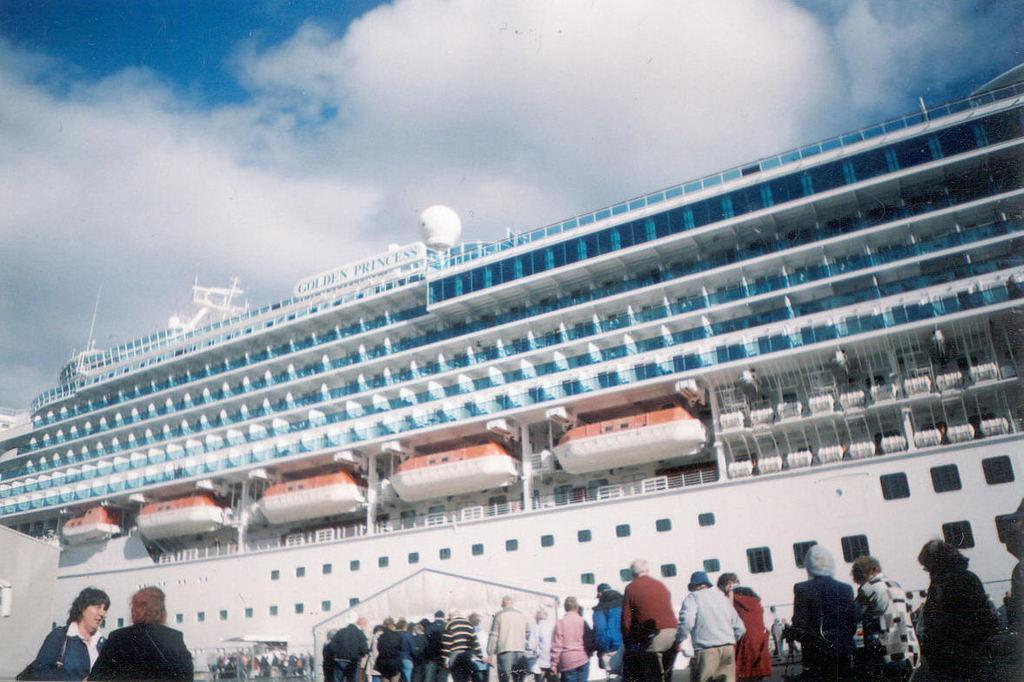What is the main subject of the image? The main subject of the image is a ship. What else can be seen at the bottom of the image? There are people at the bottom of the image. What is visible in the background of the image? The sky and clouds are visible in the background of the image. What type of garden can be seen on the ship in the image? There is no garden present on the ship in the image. 